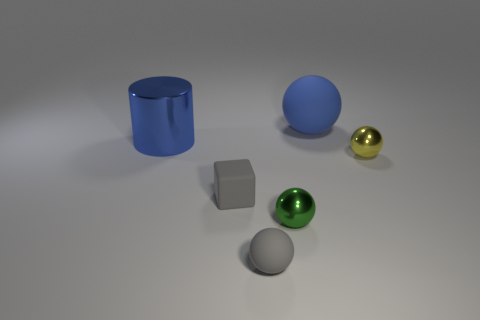Subtract all gray spheres. How many spheres are left? 3 Subtract all gray balls. How many balls are left? 3 Add 1 small cyan cylinders. How many objects exist? 7 Subtract all cylinders. How many objects are left? 5 Add 6 gray matte balls. How many gray matte balls are left? 7 Add 3 large blue matte things. How many large blue matte things exist? 4 Subtract 0 purple cylinders. How many objects are left? 6 Subtract 1 cylinders. How many cylinders are left? 0 Subtract all red cylinders. Subtract all yellow balls. How many cylinders are left? 1 Subtract all purple cylinders. How many red cubes are left? 0 